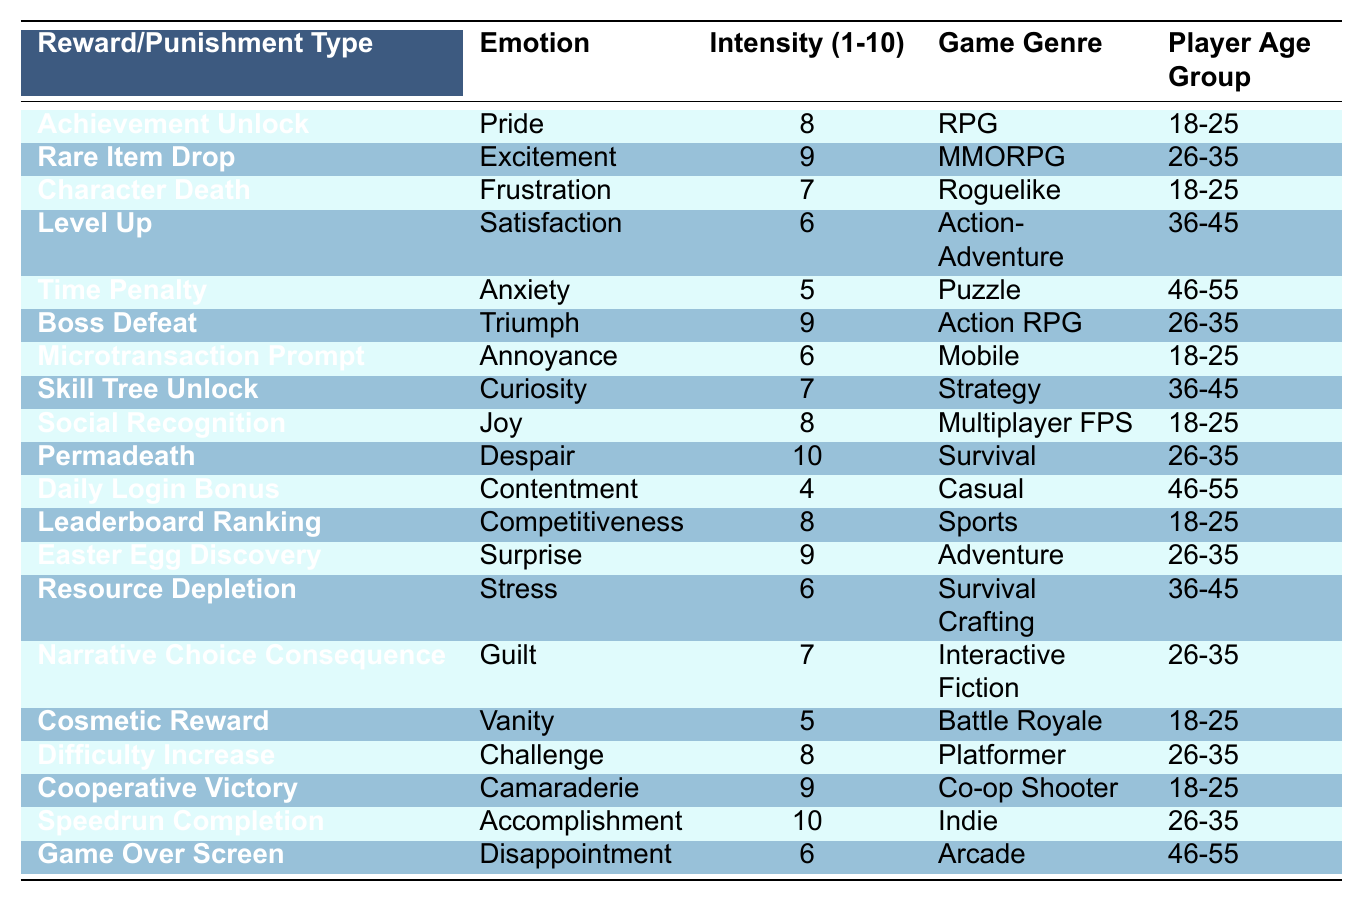What is the emotion associated with the "Rare Item Drop"? The table directly lists the emotion next to the "Rare Item Drop," which is "Excitement."
Answer: Excitement What is the intensity rating for "Achievement Unlock"? Looking at the table, "Achievement Unlock" has an intensity rating of 8.
Answer: 8 Which game genre has the most intense emotional response according to the table? The table indicates that "Permadeath" has the highest intensity rating of 10, and it falls under the "Survival" genre.
Answer: Survival How many different emotions are associated with the "18-25" age group? By examining the table, there are 6 unique emotions related to the "18-25" age group: Pride, Frustration, Annoyance, Joy, Vanity, and Camaraderie.
Answer: 6 What is the average intensity rating for "Puzzle" genre rewards and punishments? The only entry for the "Puzzle" genre in the table is "Time Penalty," which has an intensity of 5. Since there's only one entry, the average is 5.
Answer: 5 Is "Disappointment" the only emotion associated with the "Game Over Screen"? Referring to the table, "Game Over Screen" has the emotion "Disappointment," and there are no other emotions listed for this type. Thus, the statement is true.
Answer: Yes What is the difference between the maximum and minimum intensity ratings in the table? The maximum intensity is 10 (for "Permadeath" and "Speedrun Completion"), and the minimum is 4 (for "Daily Login Bonus"). The difference is 10 - 4 = 6.
Answer: 6 What emotions are tied to the "Survival Crafting" genre, and how intense are they? The table shows that "Survival Crafting" is associated with the emotion "Stress," which has an intensity rating of 6.
Answer: Stress, 6 How does the intensity of emotions for "Multiplayer FPS" compare to "Mobile" games? "Multiplayer FPS" has an emotion of "Joy" rated at 8, while "Mobile" has "Annoyance" with an intensity of 6. Thus, "Multiplayer FPS" has a higher intensity.
Answer: Higher intensity for Multiplayer FPS In which game genre do players aged 26-35 report the highest emotional intensity? Among the entries for the 26-35 age group, both "Permadeath" and "Speedrun Completion" report an intensity of 10, making them the highest.
Answer: Survival and Indie 